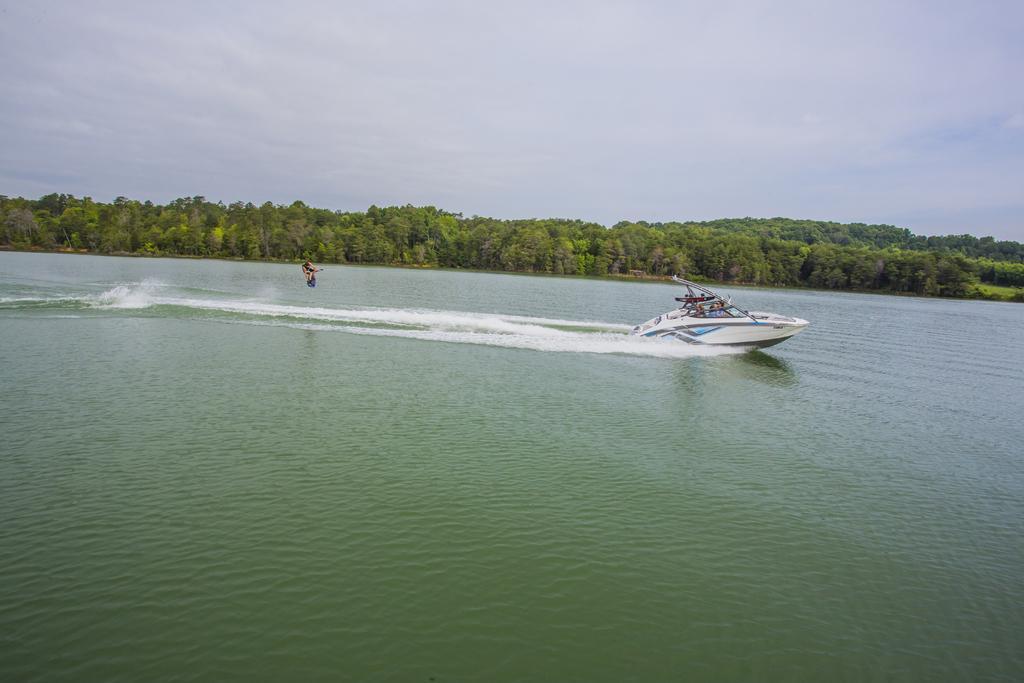In one or two sentences, can you explain what this image depicts? In this image we can see persons riding steamer boat, trees and sky with clouds. 